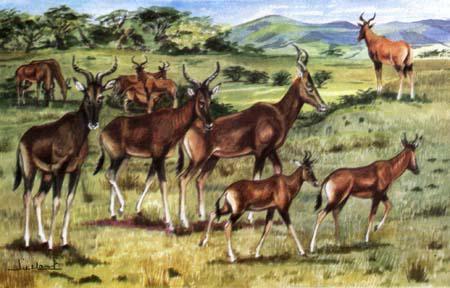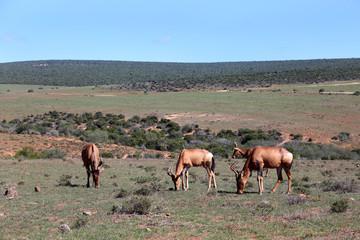The first image is the image on the left, the second image is the image on the right. For the images displayed, is the sentence "The antelope in the left image furthest to the left is facing towards the left." factually correct? Answer yes or no. No. 